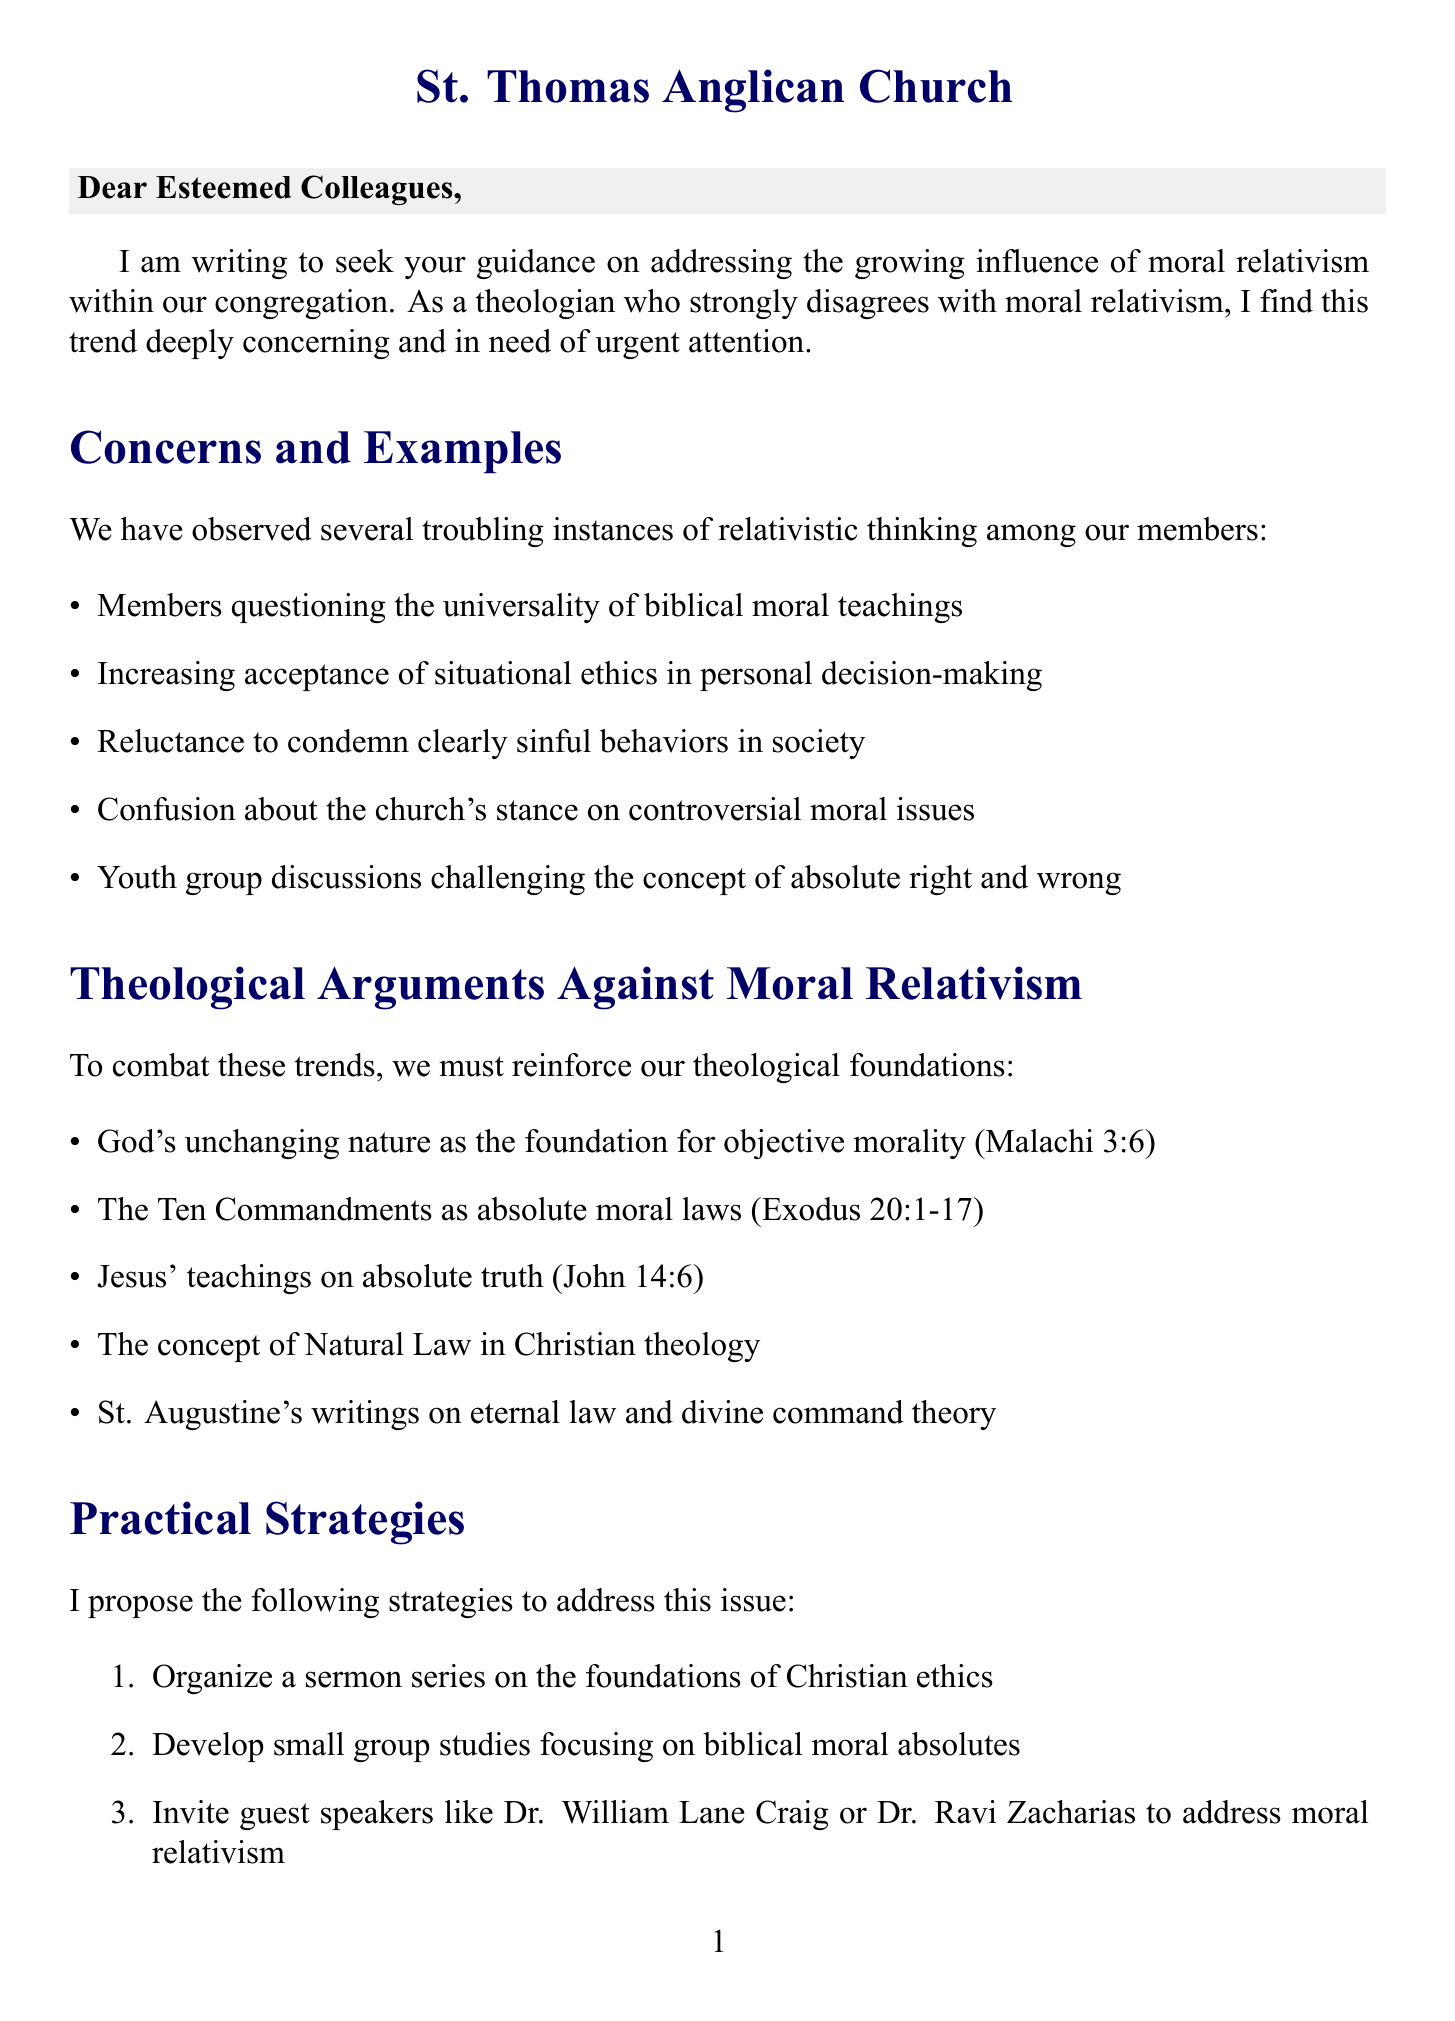What is the main concern addressed in the letter? The letter expresses concern about the growing influence of moral relativism within the congregation.
Answer: Moral relativism Who is the author of the letter? The author identifies themselves as the pastor of St. Thomas Anglican Church.
Answer: [Your Name] What are the proposed strategies for addressing moral relativism? The letter outlines several strategies, including organizing a sermon series and developing small group studies.
Answer: Sermon series Which scripture references God's unchanging nature? The letter cites Malachi 3:6 as the reference to God's unchanging nature.
Answer: Malachi 3:6 What is one example of relativistic thinking mentioned? The letter discusses members questioning the universality of biblical moral teachings as an example.
Answer: Questioning universality How many theological arguments against moral relativism are provided? The number of theological arguments presented in the letter is five.
Answer: Five What kind of resources does the author request? The author requests recommendations for readings on Christian responses to moral relativism.
Answer: Recommended readings Which famous Christian apologist is mentioned as a potential guest speaker? The letter mentions inviting Dr. William Lane Craig to address moral relativism.
Answer: Dr. William Lane Craig What is the closing statement of the letter? The closing statement expresses faith and fellowship.
Answer: In faith and fellowship 